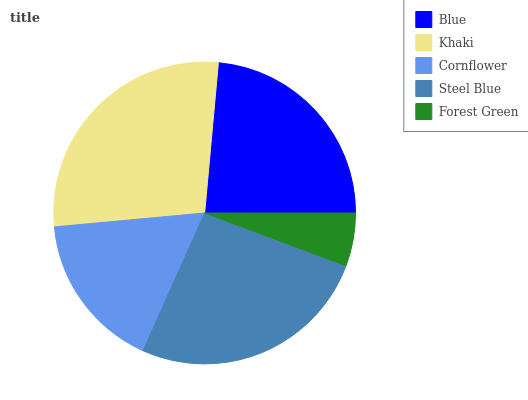Is Forest Green the minimum?
Answer yes or no. Yes. Is Khaki the maximum?
Answer yes or no. Yes. Is Cornflower the minimum?
Answer yes or no. No. Is Cornflower the maximum?
Answer yes or no. No. Is Khaki greater than Cornflower?
Answer yes or no. Yes. Is Cornflower less than Khaki?
Answer yes or no. Yes. Is Cornflower greater than Khaki?
Answer yes or no. No. Is Khaki less than Cornflower?
Answer yes or no. No. Is Blue the high median?
Answer yes or no. Yes. Is Blue the low median?
Answer yes or no. Yes. Is Cornflower the high median?
Answer yes or no. No. Is Cornflower the low median?
Answer yes or no. No. 